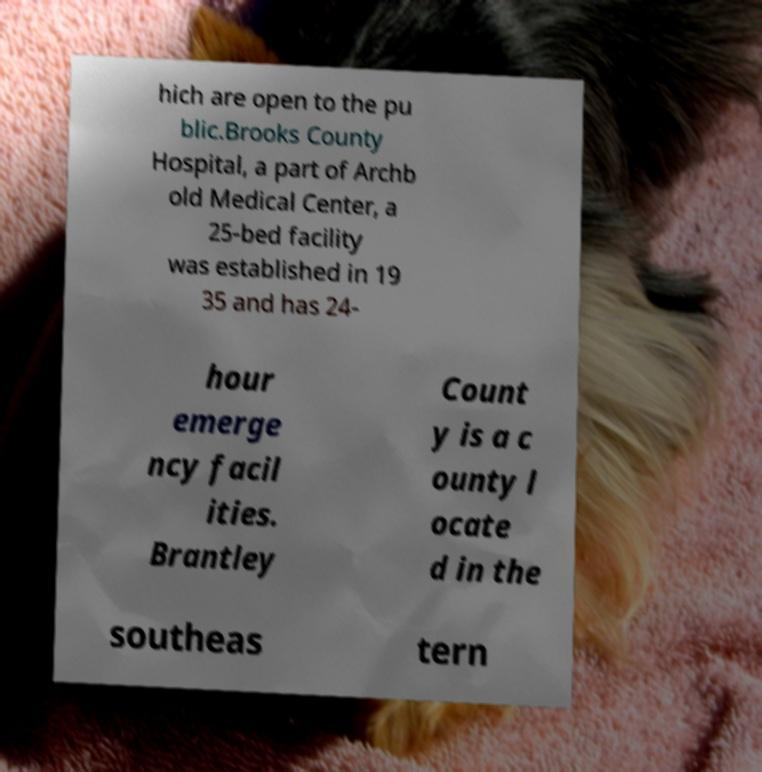I need the written content from this picture converted into text. Can you do that? hich are open to the pu blic.Brooks County Hospital, a part of Archb old Medical Center, a 25-bed facility was established in 19 35 and has 24- hour emerge ncy facil ities. Brantley Count y is a c ounty l ocate d in the southeas tern 